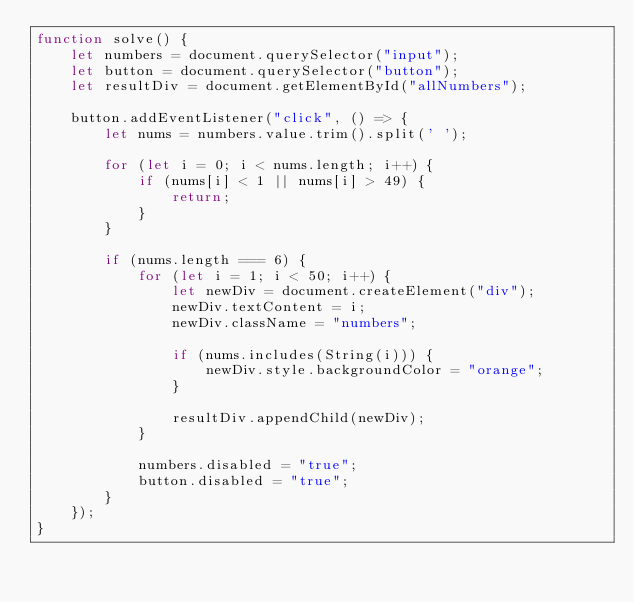Convert code to text. <code><loc_0><loc_0><loc_500><loc_500><_JavaScript_>function solve() {
    let numbers = document.querySelector("input");
    let button = document.querySelector("button");
    let resultDiv = document.getElementById("allNumbers");

    button.addEventListener("click", () => {
        let nums = numbers.value.trim().split(' ');

        for (let i = 0; i < nums.length; i++) {
            if (nums[i] < 1 || nums[i] > 49) {
                return;
            }
        }

        if (nums.length === 6) {
            for (let i = 1; i < 50; i++) {
                let newDiv = document.createElement("div");
                newDiv.textContent = i;
                newDiv.className = "numbers";

                if (nums.includes(String(i))) {
                    newDiv.style.backgroundColor = "orange";
                }

                resultDiv.appendChild(newDiv);
            }

            numbers.disabled = "true";
            button.disabled = "true";
        }
    });
}</code> 